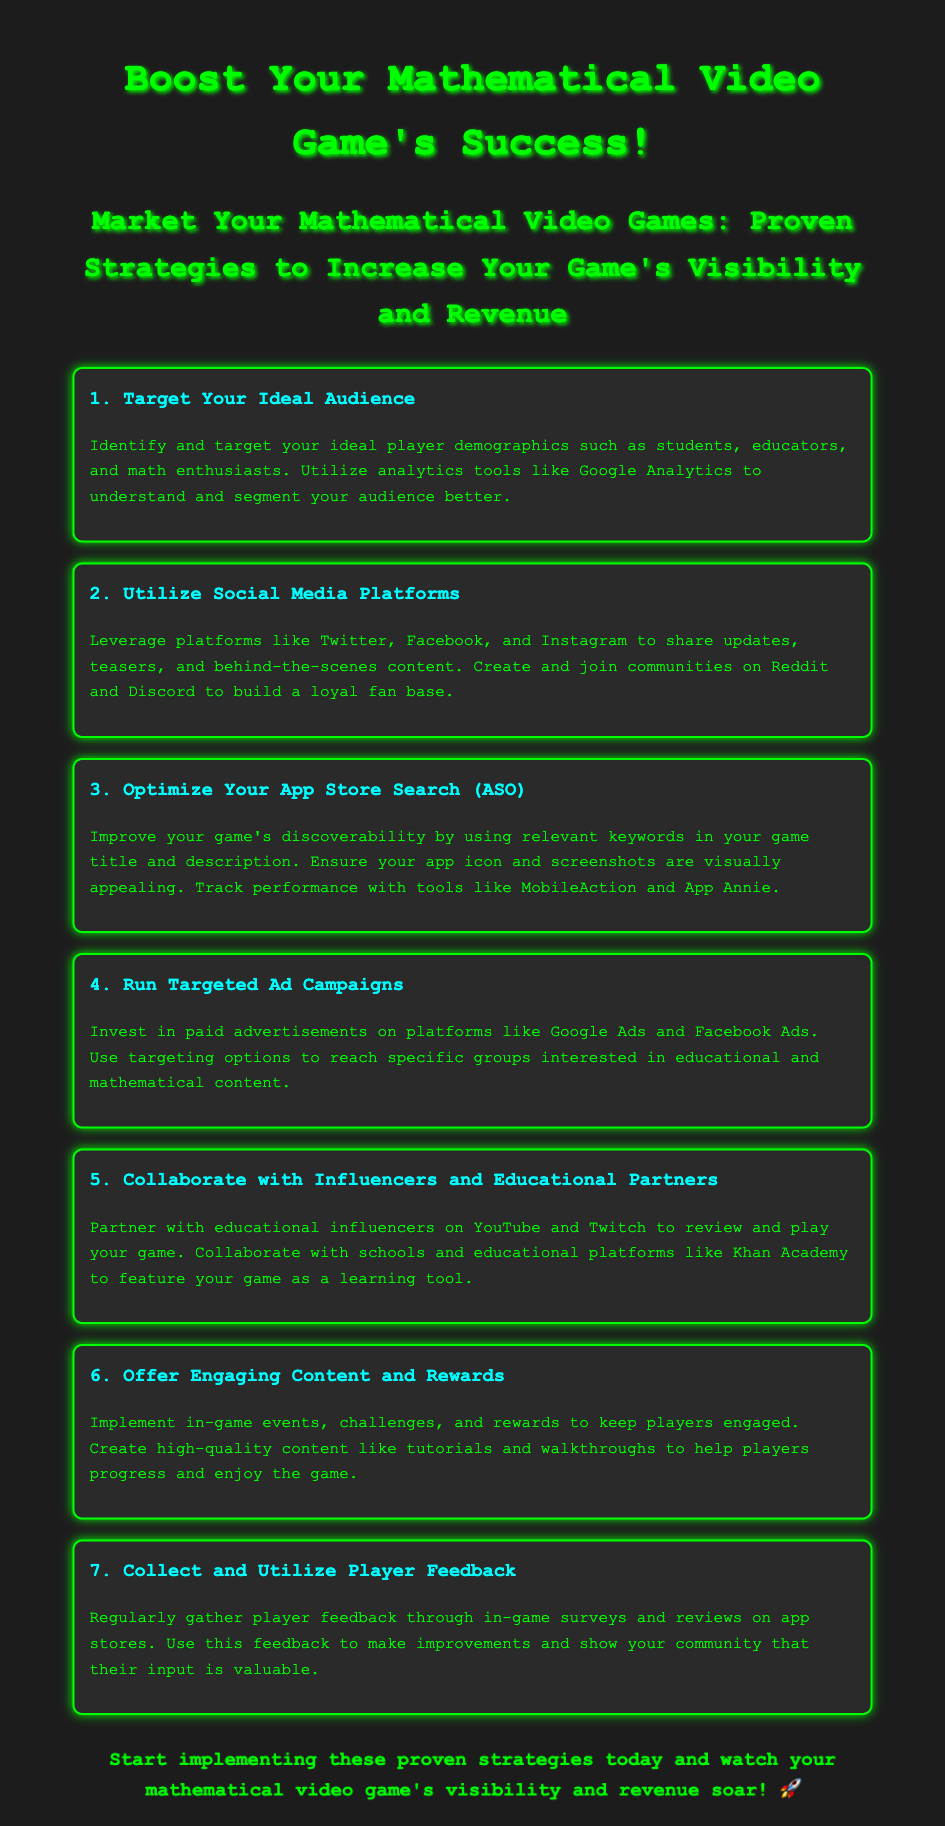What is the target audience for mathematical video games? The target audience includes students, educators, and math enthusiasts.
Answer: students, educators, and math enthusiasts What should be utilized to understand and segment the audience? Analytics tools like Google Analytics should be used for this purpose.
Answer: Google Analytics Which social media platforms are recommended for marketing? Twitter, Facebook, and Instagram are suggested for sharing updates and content.
Answer: Twitter, Facebook, and Instagram What is the main focus of App Store Optimization? The focus is on using relevant keywords in the game title and description.
Answer: relevant keywords Which advertising platforms are mentioned for targeted ad campaigns? Google Ads and Facebook Ads are the platforms to invest in for ads.
Answer: Google Ads and Facebook Ads What type of influencers should game developers collaborate with? Developers should partner with educational influencers on YouTube and Twitch.
Answer: educational influencers on YouTube and Twitch What is a suggested method for keeping players engaged? Implementing in-game events, challenges, and rewards is recommended.
Answer: in-game events, challenges, and rewards How should player feedback be gathered? Player feedback should be collected through in-game surveys and app store reviews.
Answer: in-game surveys and app store reviews 